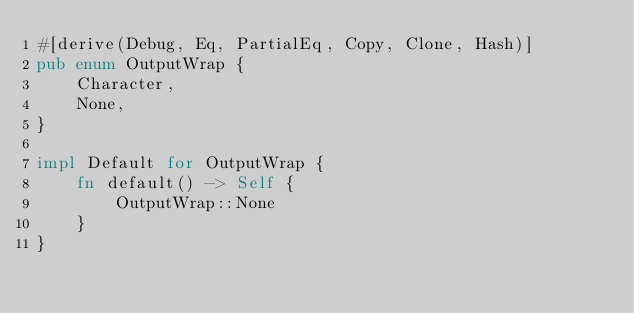Convert code to text. <code><loc_0><loc_0><loc_500><loc_500><_Rust_>#[derive(Debug, Eq, PartialEq, Copy, Clone, Hash)]
pub enum OutputWrap {
    Character,
    None,
}

impl Default for OutputWrap {
    fn default() -> Self {
        OutputWrap::None
    }
}
</code> 